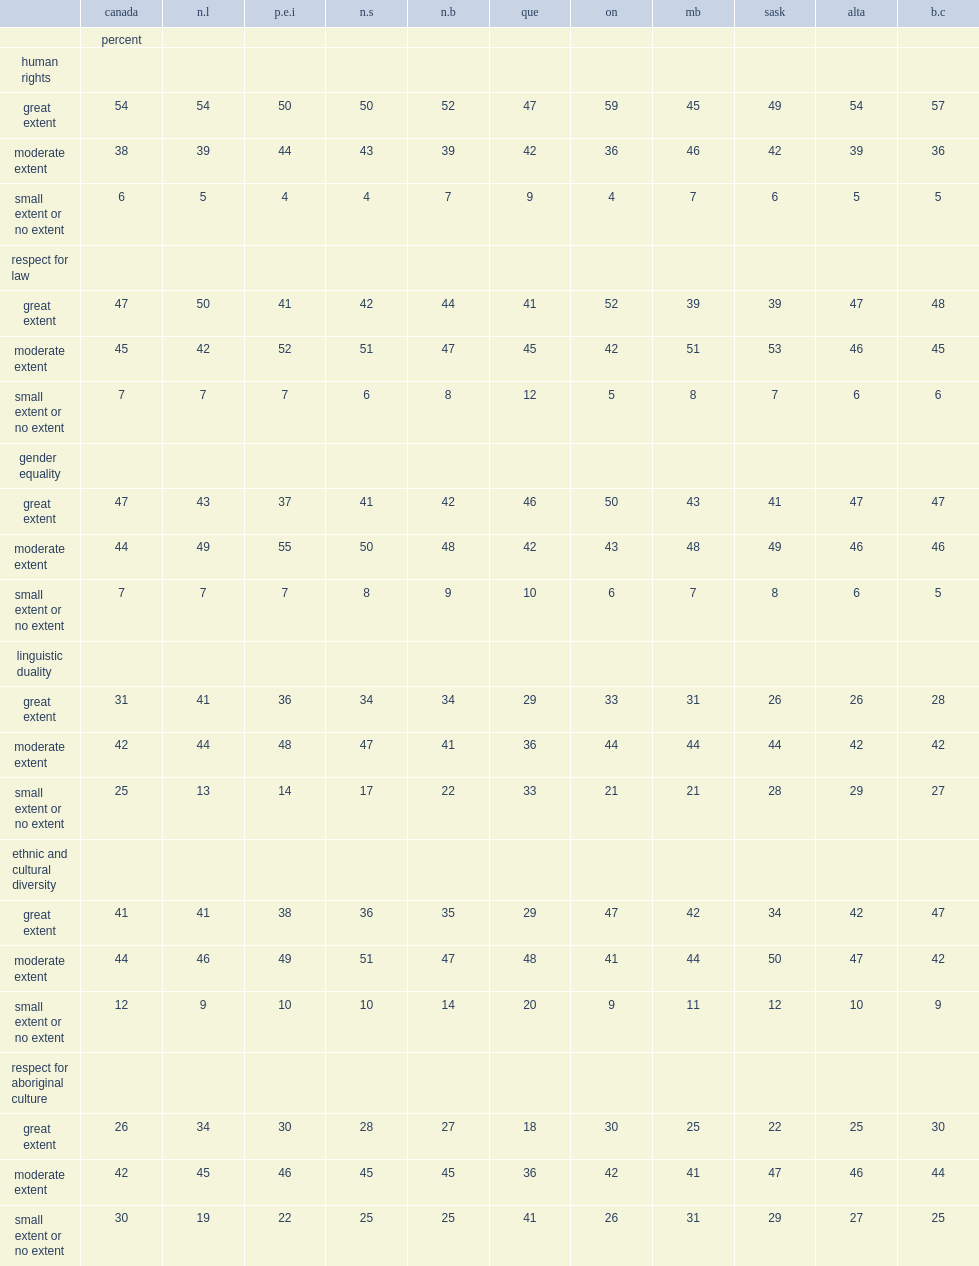What percent of ontarians strongly believed that canadians valued ethnic and cultural diversity? 47.0. What percent of canadians strongly believed that canadians valued ethnic and cultural diversity. 41. 